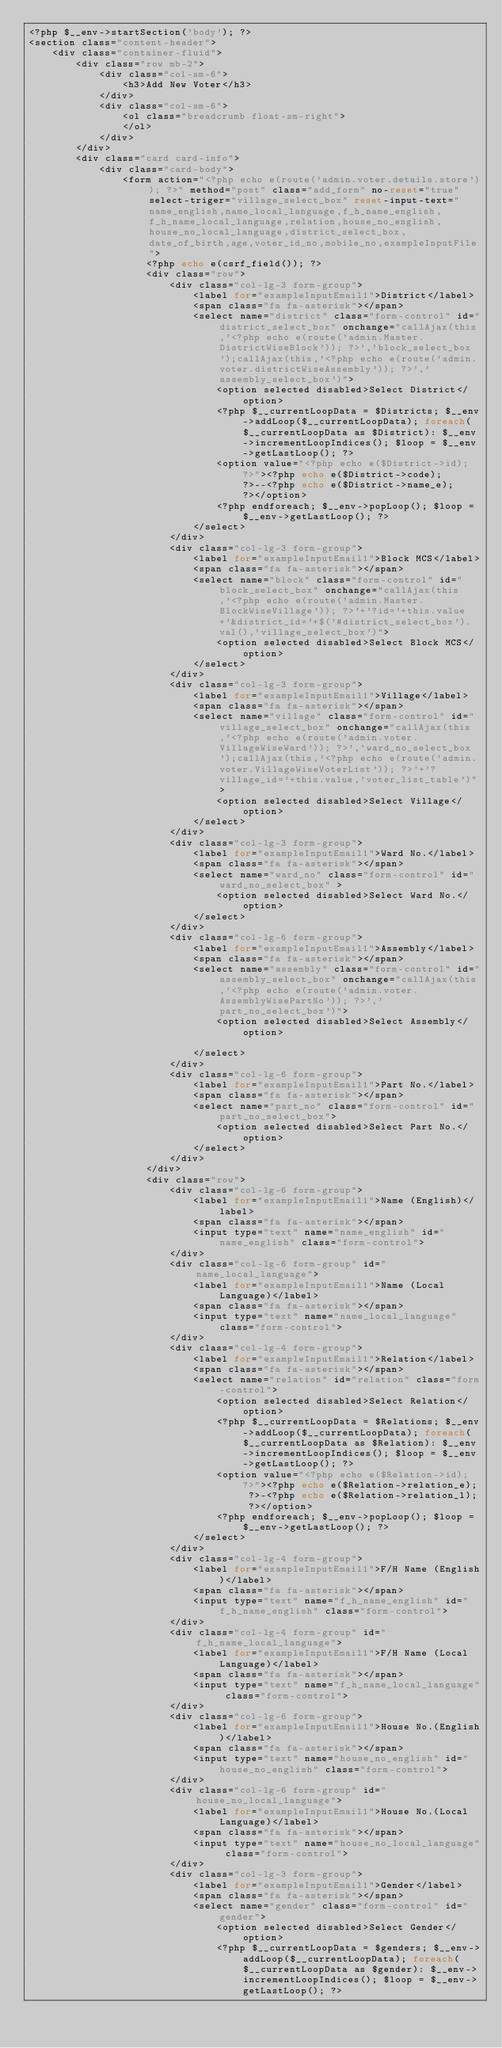Convert code to text. <code><loc_0><loc_0><loc_500><loc_500><_PHP_><?php $__env->startSection('body'); ?>
<section class="content-header">
    <div class="container-fluid">
        <div class="row mb-2">
            <div class="col-sm-6">
                <h3>Add New Voter</h3>
            </div>
            <div class="col-sm-6">
                <ol class="breadcrumb float-sm-right"> 
                </ol>
            </div>
        </div> 
        <div class="card card-info"> 
            <div class="card-body"> 
                <form action="<?php echo e(route('admin.voter.details.store')); ?>" method="post" class="add_form" no-reset="true" select-triger="village_select_box" reset-input-text="name_english,name_local_language,f_h_name_english,f_h_name_local_language,relation,house_no_english,house_no_local_language,district_select_box,date_of_birth,age,voter_id_no,mobile_no,exampleInputFile">
                    <?php echo e(csrf_field()); ?> 
                    <div class="row">  
                        <div class="col-lg-3 form-group">
                            <label for="exampleInputEmail1">District</label>
                            <span class="fa fa-asterisk"></span>
                            <select name="district" class="form-control" id="district_select_box" onchange="callAjax(this,'<?php echo e(route('admin.Master.DistrictWiseBlock')); ?>','block_select_box');callAjax(this,'<?php echo e(route('admin.voter.districtWiseAssembly')); ?>','assembly_select_box')">
                                <option selected disabled>Select District</option>
                                <?php $__currentLoopData = $Districts; $__env->addLoop($__currentLoopData); foreach($__currentLoopData as $District): $__env->incrementLoopIndices(); $loop = $__env->getLastLoop(); ?>
                                <option value="<?php echo e($District->id); ?>"><?php echo e($District->code); ?>--<?php echo e($District->name_e); ?></option>  
                                <?php endforeach; $__env->popLoop(); $loop = $__env->getLastLoop(); ?>
                            </select>
                        </div>
                        <div class="col-lg-3 form-group">
                            <label for="exampleInputEmail1">Block MCS</label>
                            <span class="fa fa-asterisk"></span>
                            <select name="block" class="form-control" id="block_select_box" onchange="callAjax(this,'<?php echo e(route('admin.Master.BlockWiseVillage')); ?>'+'?id='+this.value+'&district_id='+$('#district_select_box').val(),'village_select_box')">
                                <option selected disabled>Select Block MCS</option> 
                            </select>
                        </div> 
                        <div class="col-lg-3 form-group">
                            <label for="exampleInputEmail1">Village</label>
                            <span class="fa fa-asterisk"></span>
                            <select name="village" class="form-control" id="village_select_box" onchange="callAjax(this,'<?php echo e(route('admin.voter.VillageWiseWard')); ?>','ward_no_select_box');callAjax(this,'<?php echo e(route('admin.voter.VillageWiseVoterList')); ?>'+'?village_id='+this.value,'voter_list_table')">
                                <option selected disabled>Select Village</option> 
                            </select>
                        </div>
                        <div class="col-lg-3 form-group">
                            <label for="exampleInputEmail1">Ward No.</label>
                            <span class="fa fa-asterisk"></span>
                            <select name="ward_no" class="form-control" id="ward_no_select_box" >
                                <option selected disabled>Select Ward No.</option> 
                            </select>
                        </div>
                        <div class="col-lg-6 form-group">
                            <label for="exampleInputEmail1">Assembly</label>
                            <span class="fa fa-asterisk"></span>
                            <select name="assembly" class="form-control" id="assembly_select_box" onchange="callAjax(this,'<?php echo e(route('admin.voter.AssemblyWisePartNo')); ?>','part_no_select_box')">
                                <option selected disabled>Select Assembly</option>
                                 
                            </select>
                        </div>
                        <div class="col-lg-6 form-group">
                            <label for="exampleInputEmail1">Part No.</label>
                            <span class="fa fa-asterisk"></span>
                            <select name="part_no" class="form-control" id="part_no_select_box">
                                <option selected disabled>Select Part No.</option> 
                            </select>
                        </div> 
                    </div> 
                    <div class="row"> 
                        <div class="col-lg-6 form-group">
                            <label for="exampleInputEmail1">Name (English)</label>
                            <span class="fa fa-asterisk"></span>
                            <input type="text" name="name_english" id="name_english" class="form-control">
                        </div>
                        <div class="col-lg-6 form-group" id="name_local_language">
                            <label for="exampleInputEmail1">Name (Local Language)</label>
                            <span class="fa fa-asterisk"></span>
                            <input type="text" name="name_local_language"  class="form-control">
                        </div>
                        <div class="col-lg-4 form-group">
                            <label for="exampleInputEmail1">Relation</label>
                            <span class="fa fa-asterisk"></span>
                            <select name="relation" id="relation" class="form-control">
                                <option selected disabled>Select Relation</option>
                                <?php $__currentLoopData = $Relations; $__env->addLoop($__currentLoopData); foreach($__currentLoopData as $Relation): $__env->incrementLoopIndices(); $loop = $__env->getLastLoop(); ?>
                                <option value="<?php echo e($Relation->id); ?>"><?php echo e($Relation->relation_e); ?>-<?php echo e($Relation->relation_l); ?></option> 
                                <?php endforeach; $__env->popLoop(); $loop = $__env->getLastLoop(); ?> 
                            </select>
                        </div>
                        <div class="col-lg-4 form-group">
                            <label for="exampleInputEmail1">F/H Name (English)</label>
                            <span class="fa fa-asterisk"></span>
                            <input type="text" name="f_h_name_english" id="f_h_name_english" class="form-control">
                        </div>
                        <div class="col-lg-4 form-group" id="f_h_name_local_language">
                            <label for="exampleInputEmail1">F/H Name (Local Language)</label>
                            <span class="fa fa-asterisk"></span>
                            <input type="text" name="f_h_name_local_language" class="form-control">
                        </div> 
                        <div class="col-lg-6 form-group">
                            <label for="exampleInputEmail1">House No.(English)</label>
                            <span class="fa fa-asterisk"></span>
                            <input type="text" name="house_no_english" id="house_no_english" class="form-control">
                        </div>
                        <div class="col-lg-6 form-group" id="house_no_local_language">
                            <label for="exampleInputEmail1">House No.(Local Language)</label>
                            <span class="fa fa-asterisk"></span>
                            <input type="text" name="house_no_local_language" class="form-control">
                        </div>
                        <div class="col-lg-3 form-group">
                            <label for="exampleInputEmail1">Gender</label>
                            <span class="fa fa-asterisk"></span>
                            <select name="gender" class="form-control" id="gender">
                                <option selected disabled>Select Gender</option>
                                <?php $__currentLoopData = $genders; $__env->addLoop($__currentLoopData); foreach($__currentLoopData as $gender): $__env->incrementLoopIndices(); $loop = $__env->getLastLoop(); ?></code> 